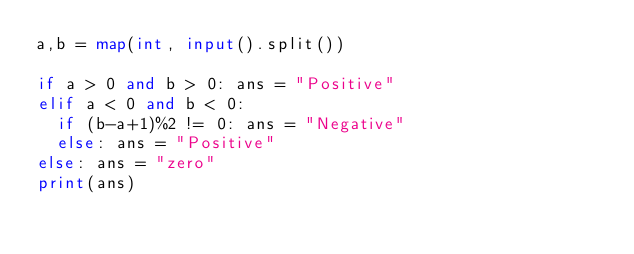<code> <loc_0><loc_0><loc_500><loc_500><_Python_>a,b = map(int, input().split())

if a > 0 and b > 0: ans = "Positive"
elif a < 0 and b < 0:
  if (b-a+1)%2 != 0: ans = "Negative"
  else: ans = "Positive"
else: ans = "zero"
print(ans)</code> 